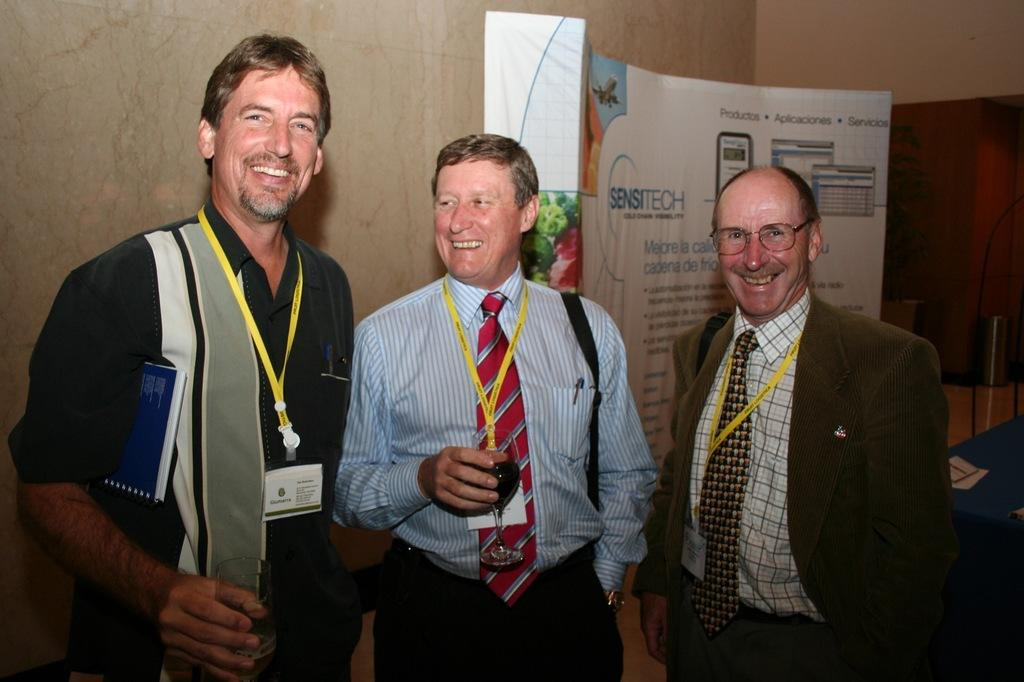How many people are in the image? There are three people in the image. What are the people doing in the image? The people are standing and smiling. What are the people holding in the image? The people are holding wine glasses. What can be seen on the people's clothing in the image? The people are wearing ID cards. What is visible in the background of the image? There is a banner visible in the background. Can you see a snake slithering through the yard in the image? There is no snake or yard present in the image; it features three people standing and smiling while holding wine glasses. 